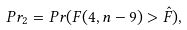Convert formula to latex. <formula><loc_0><loc_0><loc_500><loc_500>P r _ { 2 } = P r ( F ( 4 , n - 9 ) > \hat { F } ) ,</formula> 